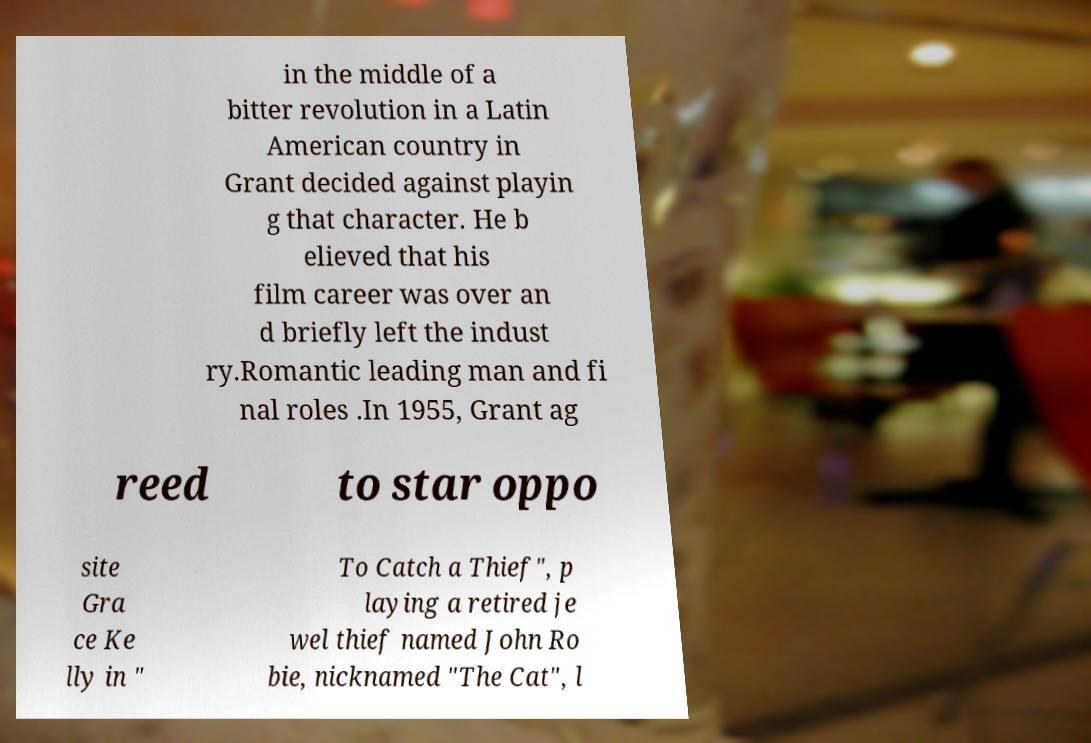Could you assist in decoding the text presented in this image and type it out clearly? in the middle of a bitter revolution in a Latin American country in Grant decided against playin g that character. He b elieved that his film career was over an d briefly left the indust ry.Romantic leading man and fi nal roles .In 1955, Grant ag reed to star oppo site Gra ce Ke lly in " To Catch a Thief", p laying a retired je wel thief named John Ro bie, nicknamed "The Cat", l 